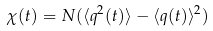Convert formula to latex. <formula><loc_0><loc_0><loc_500><loc_500>\chi ( t ) = N ( \langle q ^ { 2 } ( t ) \rangle - \langle q ( t ) \rangle ^ { 2 } )</formula> 